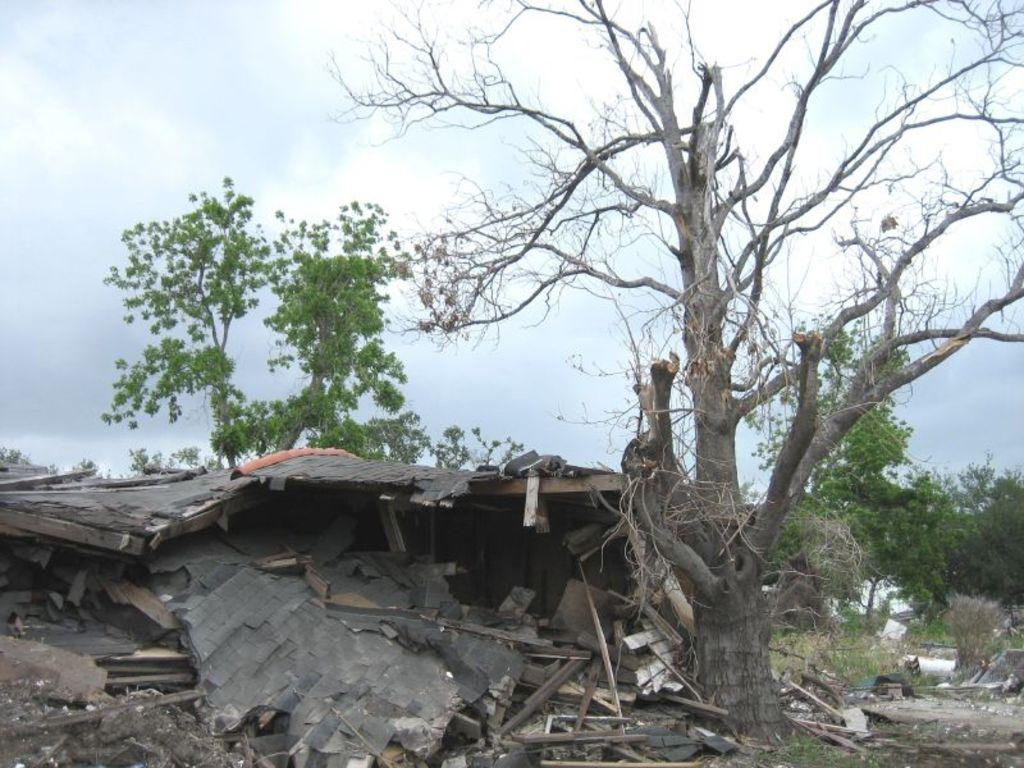What is the main subject of the image? The main subject of the image is a collapsed house. What can be seen behind the collapsed house? There are trees visible behind the collapsed house. What is visible in the sky in the image? The sky is visible in the image. What type of tray is being used to hold the collapsed house in the image? There is no tray present in the image; the house has collapsed on its own. 